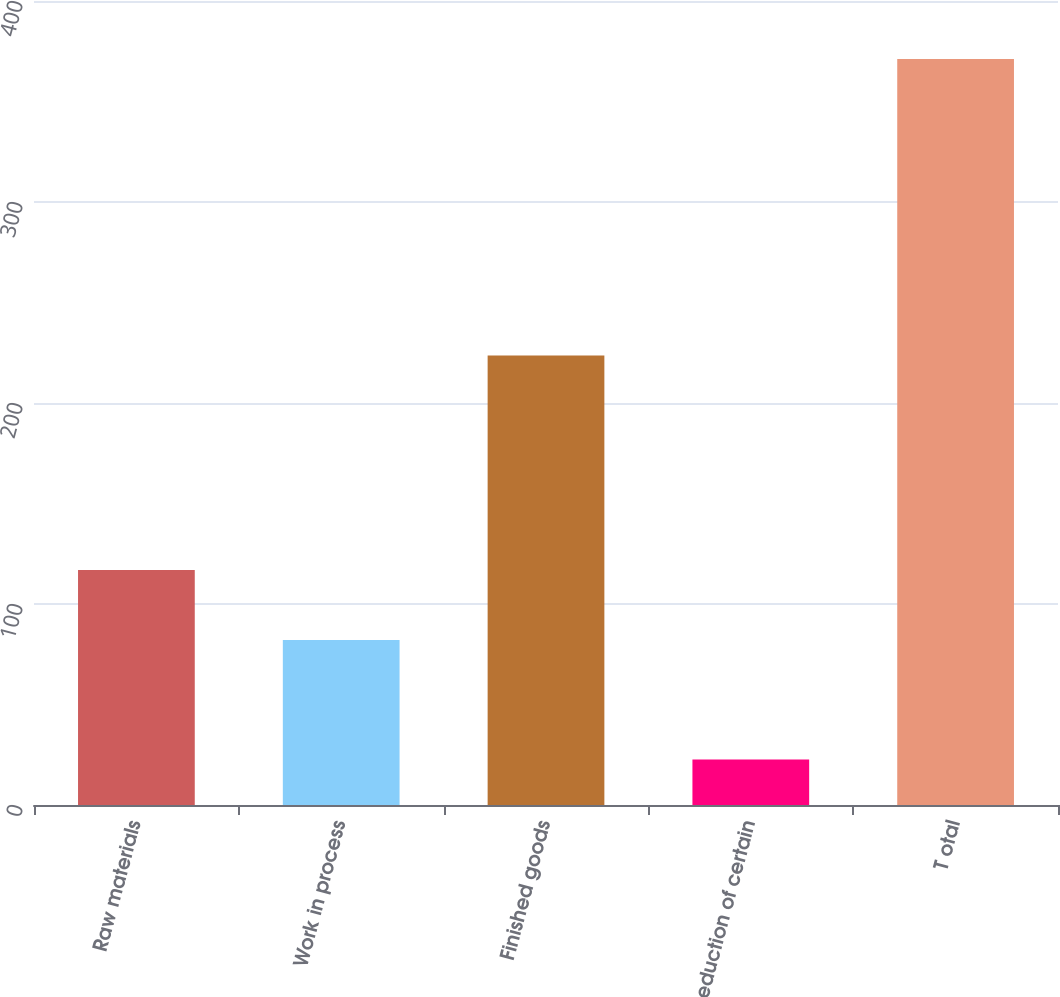Convert chart to OTSL. <chart><loc_0><loc_0><loc_500><loc_500><bar_chart><fcel>Raw materials<fcel>Work in process<fcel>Finished goods<fcel>Reduction of certain<fcel>T otal<nl><fcel>116.96<fcel>82.1<fcel>223.6<fcel>22.6<fcel>371.2<nl></chart> 